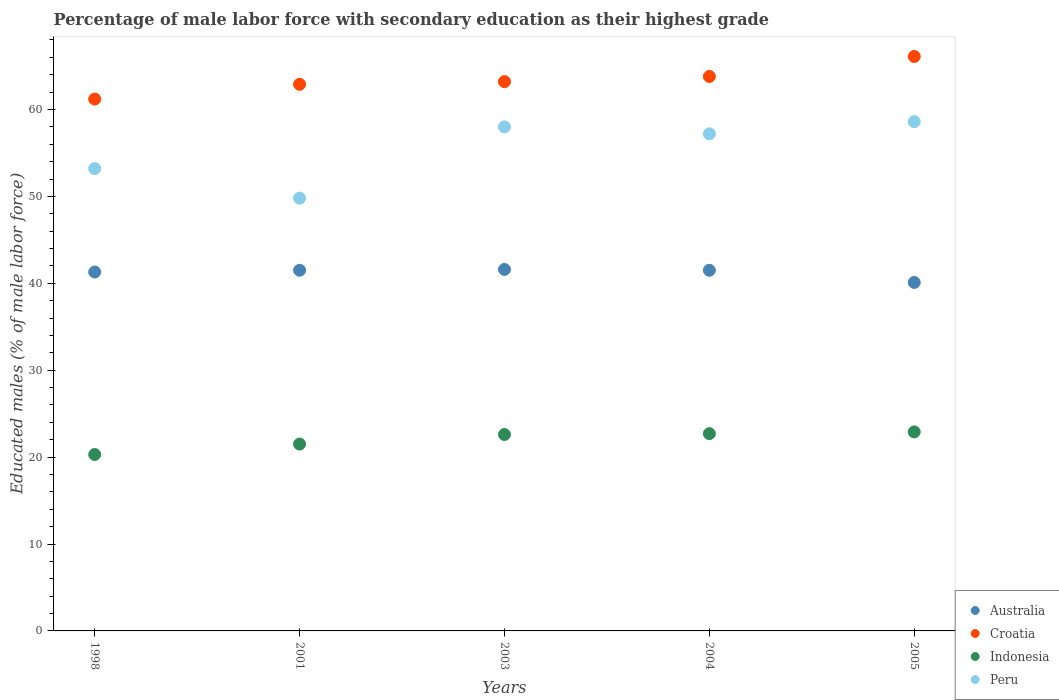How many different coloured dotlines are there?
Provide a short and direct response. 4. What is the percentage of male labor force with secondary education in Peru in 1998?
Offer a very short reply. 53.2. Across all years, what is the maximum percentage of male labor force with secondary education in Croatia?
Provide a short and direct response. 66.1. Across all years, what is the minimum percentage of male labor force with secondary education in Indonesia?
Your answer should be very brief. 20.3. In which year was the percentage of male labor force with secondary education in Indonesia minimum?
Provide a short and direct response. 1998. What is the total percentage of male labor force with secondary education in Indonesia in the graph?
Make the answer very short. 110. What is the difference between the percentage of male labor force with secondary education in Croatia in 2004 and that in 2005?
Make the answer very short. -2.3. What is the difference between the percentage of male labor force with secondary education in Peru in 1998 and the percentage of male labor force with secondary education in Croatia in 2004?
Your answer should be compact. -10.6. What is the average percentage of male labor force with secondary education in Australia per year?
Your answer should be very brief. 41.2. In the year 2004, what is the difference between the percentage of male labor force with secondary education in Croatia and percentage of male labor force with secondary education in Indonesia?
Make the answer very short. 41.1. In how many years, is the percentage of male labor force with secondary education in Australia greater than 58 %?
Keep it short and to the point. 0. What is the ratio of the percentage of male labor force with secondary education in Indonesia in 1998 to that in 2001?
Make the answer very short. 0.94. Is the difference between the percentage of male labor force with secondary education in Croatia in 2003 and 2005 greater than the difference between the percentage of male labor force with secondary education in Indonesia in 2003 and 2005?
Offer a terse response. No. What is the difference between the highest and the second highest percentage of male labor force with secondary education in Australia?
Make the answer very short. 0.1. What is the difference between the highest and the lowest percentage of male labor force with secondary education in Australia?
Your response must be concise. 1.5. In how many years, is the percentage of male labor force with secondary education in Peru greater than the average percentage of male labor force with secondary education in Peru taken over all years?
Your answer should be very brief. 3. Is the percentage of male labor force with secondary education in Peru strictly less than the percentage of male labor force with secondary education in Australia over the years?
Your answer should be very brief. No. How many years are there in the graph?
Keep it short and to the point. 5. What is the difference between two consecutive major ticks on the Y-axis?
Give a very brief answer. 10. How many legend labels are there?
Make the answer very short. 4. How are the legend labels stacked?
Offer a terse response. Vertical. What is the title of the graph?
Your answer should be very brief. Percentage of male labor force with secondary education as their highest grade. Does "Bosnia and Herzegovina" appear as one of the legend labels in the graph?
Offer a very short reply. No. What is the label or title of the Y-axis?
Your response must be concise. Educated males (% of male labor force). What is the Educated males (% of male labor force) of Australia in 1998?
Your answer should be compact. 41.3. What is the Educated males (% of male labor force) of Croatia in 1998?
Provide a short and direct response. 61.2. What is the Educated males (% of male labor force) of Indonesia in 1998?
Your answer should be compact. 20.3. What is the Educated males (% of male labor force) in Peru in 1998?
Offer a terse response. 53.2. What is the Educated males (% of male labor force) of Australia in 2001?
Give a very brief answer. 41.5. What is the Educated males (% of male labor force) in Croatia in 2001?
Ensure brevity in your answer.  62.9. What is the Educated males (% of male labor force) of Indonesia in 2001?
Provide a short and direct response. 21.5. What is the Educated males (% of male labor force) in Peru in 2001?
Your answer should be compact. 49.8. What is the Educated males (% of male labor force) in Australia in 2003?
Offer a terse response. 41.6. What is the Educated males (% of male labor force) in Croatia in 2003?
Make the answer very short. 63.2. What is the Educated males (% of male labor force) in Indonesia in 2003?
Offer a very short reply. 22.6. What is the Educated males (% of male labor force) of Australia in 2004?
Your answer should be very brief. 41.5. What is the Educated males (% of male labor force) in Croatia in 2004?
Provide a succinct answer. 63.8. What is the Educated males (% of male labor force) in Indonesia in 2004?
Provide a short and direct response. 22.7. What is the Educated males (% of male labor force) of Peru in 2004?
Your answer should be very brief. 57.2. What is the Educated males (% of male labor force) in Australia in 2005?
Offer a terse response. 40.1. What is the Educated males (% of male labor force) in Croatia in 2005?
Keep it short and to the point. 66.1. What is the Educated males (% of male labor force) of Indonesia in 2005?
Give a very brief answer. 22.9. What is the Educated males (% of male labor force) of Peru in 2005?
Give a very brief answer. 58.6. Across all years, what is the maximum Educated males (% of male labor force) of Australia?
Provide a succinct answer. 41.6. Across all years, what is the maximum Educated males (% of male labor force) in Croatia?
Your answer should be very brief. 66.1. Across all years, what is the maximum Educated males (% of male labor force) of Indonesia?
Keep it short and to the point. 22.9. Across all years, what is the maximum Educated males (% of male labor force) in Peru?
Offer a terse response. 58.6. Across all years, what is the minimum Educated males (% of male labor force) of Australia?
Offer a very short reply. 40.1. Across all years, what is the minimum Educated males (% of male labor force) of Croatia?
Ensure brevity in your answer.  61.2. Across all years, what is the minimum Educated males (% of male labor force) in Indonesia?
Keep it short and to the point. 20.3. Across all years, what is the minimum Educated males (% of male labor force) of Peru?
Provide a short and direct response. 49.8. What is the total Educated males (% of male labor force) of Australia in the graph?
Give a very brief answer. 206. What is the total Educated males (% of male labor force) of Croatia in the graph?
Ensure brevity in your answer.  317.2. What is the total Educated males (% of male labor force) in Indonesia in the graph?
Your response must be concise. 110. What is the total Educated males (% of male labor force) of Peru in the graph?
Your answer should be very brief. 276.8. What is the difference between the Educated males (% of male labor force) of Australia in 1998 and that in 2001?
Your answer should be compact. -0.2. What is the difference between the Educated males (% of male labor force) in Croatia in 1998 and that in 2001?
Provide a succinct answer. -1.7. What is the difference between the Educated males (% of male labor force) of Indonesia in 1998 and that in 2001?
Offer a terse response. -1.2. What is the difference between the Educated males (% of male labor force) of Croatia in 1998 and that in 2003?
Keep it short and to the point. -2. What is the difference between the Educated males (% of male labor force) in Indonesia in 1998 and that in 2003?
Provide a short and direct response. -2.3. What is the difference between the Educated males (% of male labor force) of Peru in 1998 and that in 2003?
Your answer should be compact. -4.8. What is the difference between the Educated males (% of male labor force) of Indonesia in 2001 and that in 2003?
Provide a succinct answer. -1.1. What is the difference between the Educated males (% of male labor force) in Peru in 2001 and that in 2003?
Provide a short and direct response. -8.2. What is the difference between the Educated males (% of male labor force) of Australia in 2001 and that in 2004?
Your answer should be very brief. 0. What is the difference between the Educated males (% of male labor force) in Croatia in 2001 and that in 2004?
Offer a terse response. -0.9. What is the difference between the Educated males (% of male labor force) in Peru in 2001 and that in 2004?
Give a very brief answer. -7.4. What is the difference between the Educated males (% of male labor force) in Croatia in 2001 and that in 2005?
Offer a terse response. -3.2. What is the difference between the Educated males (% of male labor force) in Croatia in 2003 and that in 2004?
Make the answer very short. -0.6. What is the difference between the Educated males (% of male labor force) of Indonesia in 2003 and that in 2004?
Your response must be concise. -0.1. What is the difference between the Educated males (% of male labor force) in Peru in 2003 and that in 2004?
Keep it short and to the point. 0.8. What is the difference between the Educated males (% of male labor force) of Croatia in 2003 and that in 2005?
Keep it short and to the point. -2.9. What is the difference between the Educated males (% of male labor force) of Peru in 2003 and that in 2005?
Your response must be concise. -0.6. What is the difference between the Educated males (% of male labor force) of Australia in 2004 and that in 2005?
Keep it short and to the point. 1.4. What is the difference between the Educated males (% of male labor force) of Croatia in 2004 and that in 2005?
Keep it short and to the point. -2.3. What is the difference between the Educated males (% of male labor force) of Indonesia in 2004 and that in 2005?
Provide a short and direct response. -0.2. What is the difference between the Educated males (% of male labor force) of Peru in 2004 and that in 2005?
Your response must be concise. -1.4. What is the difference between the Educated males (% of male labor force) in Australia in 1998 and the Educated males (% of male labor force) in Croatia in 2001?
Make the answer very short. -21.6. What is the difference between the Educated males (% of male labor force) in Australia in 1998 and the Educated males (% of male labor force) in Indonesia in 2001?
Your answer should be very brief. 19.8. What is the difference between the Educated males (% of male labor force) in Croatia in 1998 and the Educated males (% of male labor force) in Indonesia in 2001?
Your answer should be compact. 39.7. What is the difference between the Educated males (% of male labor force) of Indonesia in 1998 and the Educated males (% of male labor force) of Peru in 2001?
Provide a succinct answer. -29.5. What is the difference between the Educated males (% of male labor force) in Australia in 1998 and the Educated males (% of male labor force) in Croatia in 2003?
Offer a very short reply. -21.9. What is the difference between the Educated males (% of male labor force) of Australia in 1998 and the Educated males (% of male labor force) of Peru in 2003?
Keep it short and to the point. -16.7. What is the difference between the Educated males (% of male labor force) of Croatia in 1998 and the Educated males (% of male labor force) of Indonesia in 2003?
Keep it short and to the point. 38.6. What is the difference between the Educated males (% of male labor force) in Indonesia in 1998 and the Educated males (% of male labor force) in Peru in 2003?
Ensure brevity in your answer.  -37.7. What is the difference between the Educated males (% of male labor force) in Australia in 1998 and the Educated males (% of male labor force) in Croatia in 2004?
Give a very brief answer. -22.5. What is the difference between the Educated males (% of male labor force) in Australia in 1998 and the Educated males (% of male labor force) in Indonesia in 2004?
Give a very brief answer. 18.6. What is the difference between the Educated males (% of male labor force) of Australia in 1998 and the Educated males (% of male labor force) of Peru in 2004?
Give a very brief answer. -15.9. What is the difference between the Educated males (% of male labor force) of Croatia in 1998 and the Educated males (% of male labor force) of Indonesia in 2004?
Give a very brief answer. 38.5. What is the difference between the Educated males (% of male labor force) in Indonesia in 1998 and the Educated males (% of male labor force) in Peru in 2004?
Offer a terse response. -36.9. What is the difference between the Educated males (% of male labor force) in Australia in 1998 and the Educated males (% of male labor force) in Croatia in 2005?
Your answer should be very brief. -24.8. What is the difference between the Educated males (% of male labor force) in Australia in 1998 and the Educated males (% of male labor force) in Peru in 2005?
Offer a terse response. -17.3. What is the difference between the Educated males (% of male labor force) of Croatia in 1998 and the Educated males (% of male labor force) of Indonesia in 2005?
Give a very brief answer. 38.3. What is the difference between the Educated males (% of male labor force) of Croatia in 1998 and the Educated males (% of male labor force) of Peru in 2005?
Provide a succinct answer. 2.6. What is the difference between the Educated males (% of male labor force) of Indonesia in 1998 and the Educated males (% of male labor force) of Peru in 2005?
Ensure brevity in your answer.  -38.3. What is the difference between the Educated males (% of male labor force) of Australia in 2001 and the Educated males (% of male labor force) of Croatia in 2003?
Make the answer very short. -21.7. What is the difference between the Educated males (% of male labor force) of Australia in 2001 and the Educated males (% of male labor force) of Peru in 2003?
Make the answer very short. -16.5. What is the difference between the Educated males (% of male labor force) in Croatia in 2001 and the Educated males (% of male labor force) in Indonesia in 2003?
Give a very brief answer. 40.3. What is the difference between the Educated males (% of male labor force) of Croatia in 2001 and the Educated males (% of male labor force) of Peru in 2003?
Give a very brief answer. 4.9. What is the difference between the Educated males (% of male labor force) in Indonesia in 2001 and the Educated males (% of male labor force) in Peru in 2003?
Offer a terse response. -36.5. What is the difference between the Educated males (% of male labor force) in Australia in 2001 and the Educated males (% of male labor force) in Croatia in 2004?
Provide a short and direct response. -22.3. What is the difference between the Educated males (% of male labor force) in Australia in 2001 and the Educated males (% of male labor force) in Peru in 2004?
Make the answer very short. -15.7. What is the difference between the Educated males (% of male labor force) in Croatia in 2001 and the Educated males (% of male labor force) in Indonesia in 2004?
Offer a terse response. 40.2. What is the difference between the Educated males (% of male labor force) in Indonesia in 2001 and the Educated males (% of male labor force) in Peru in 2004?
Provide a succinct answer. -35.7. What is the difference between the Educated males (% of male labor force) in Australia in 2001 and the Educated males (% of male labor force) in Croatia in 2005?
Offer a very short reply. -24.6. What is the difference between the Educated males (% of male labor force) of Australia in 2001 and the Educated males (% of male labor force) of Indonesia in 2005?
Ensure brevity in your answer.  18.6. What is the difference between the Educated males (% of male labor force) in Australia in 2001 and the Educated males (% of male labor force) in Peru in 2005?
Offer a terse response. -17.1. What is the difference between the Educated males (% of male labor force) of Croatia in 2001 and the Educated males (% of male labor force) of Indonesia in 2005?
Offer a very short reply. 40. What is the difference between the Educated males (% of male labor force) of Croatia in 2001 and the Educated males (% of male labor force) of Peru in 2005?
Ensure brevity in your answer.  4.3. What is the difference between the Educated males (% of male labor force) of Indonesia in 2001 and the Educated males (% of male labor force) of Peru in 2005?
Provide a succinct answer. -37.1. What is the difference between the Educated males (% of male labor force) of Australia in 2003 and the Educated males (% of male labor force) of Croatia in 2004?
Your answer should be compact. -22.2. What is the difference between the Educated males (% of male labor force) of Australia in 2003 and the Educated males (% of male labor force) of Indonesia in 2004?
Your answer should be compact. 18.9. What is the difference between the Educated males (% of male labor force) of Australia in 2003 and the Educated males (% of male labor force) of Peru in 2004?
Offer a terse response. -15.6. What is the difference between the Educated males (% of male labor force) of Croatia in 2003 and the Educated males (% of male labor force) of Indonesia in 2004?
Provide a short and direct response. 40.5. What is the difference between the Educated males (% of male labor force) in Indonesia in 2003 and the Educated males (% of male labor force) in Peru in 2004?
Provide a succinct answer. -34.6. What is the difference between the Educated males (% of male labor force) of Australia in 2003 and the Educated males (% of male labor force) of Croatia in 2005?
Ensure brevity in your answer.  -24.5. What is the difference between the Educated males (% of male labor force) in Australia in 2003 and the Educated males (% of male labor force) in Indonesia in 2005?
Provide a succinct answer. 18.7. What is the difference between the Educated males (% of male labor force) of Croatia in 2003 and the Educated males (% of male labor force) of Indonesia in 2005?
Make the answer very short. 40.3. What is the difference between the Educated males (% of male labor force) in Indonesia in 2003 and the Educated males (% of male labor force) in Peru in 2005?
Your answer should be compact. -36. What is the difference between the Educated males (% of male labor force) in Australia in 2004 and the Educated males (% of male labor force) in Croatia in 2005?
Your response must be concise. -24.6. What is the difference between the Educated males (% of male labor force) in Australia in 2004 and the Educated males (% of male labor force) in Indonesia in 2005?
Your answer should be very brief. 18.6. What is the difference between the Educated males (% of male labor force) of Australia in 2004 and the Educated males (% of male labor force) of Peru in 2005?
Your answer should be compact. -17.1. What is the difference between the Educated males (% of male labor force) of Croatia in 2004 and the Educated males (% of male labor force) of Indonesia in 2005?
Make the answer very short. 40.9. What is the difference between the Educated males (% of male labor force) of Indonesia in 2004 and the Educated males (% of male labor force) of Peru in 2005?
Provide a succinct answer. -35.9. What is the average Educated males (% of male labor force) in Australia per year?
Your answer should be compact. 41.2. What is the average Educated males (% of male labor force) in Croatia per year?
Keep it short and to the point. 63.44. What is the average Educated males (% of male labor force) in Peru per year?
Keep it short and to the point. 55.36. In the year 1998, what is the difference between the Educated males (% of male labor force) in Australia and Educated males (% of male labor force) in Croatia?
Offer a terse response. -19.9. In the year 1998, what is the difference between the Educated males (% of male labor force) of Australia and Educated males (% of male labor force) of Peru?
Offer a very short reply. -11.9. In the year 1998, what is the difference between the Educated males (% of male labor force) in Croatia and Educated males (% of male labor force) in Indonesia?
Your answer should be compact. 40.9. In the year 1998, what is the difference between the Educated males (% of male labor force) in Indonesia and Educated males (% of male labor force) in Peru?
Your answer should be very brief. -32.9. In the year 2001, what is the difference between the Educated males (% of male labor force) in Australia and Educated males (% of male labor force) in Croatia?
Your answer should be very brief. -21.4. In the year 2001, what is the difference between the Educated males (% of male labor force) in Australia and Educated males (% of male labor force) in Indonesia?
Offer a terse response. 20. In the year 2001, what is the difference between the Educated males (% of male labor force) of Croatia and Educated males (% of male labor force) of Indonesia?
Provide a succinct answer. 41.4. In the year 2001, what is the difference between the Educated males (% of male labor force) of Croatia and Educated males (% of male labor force) of Peru?
Keep it short and to the point. 13.1. In the year 2001, what is the difference between the Educated males (% of male labor force) of Indonesia and Educated males (% of male labor force) of Peru?
Your answer should be compact. -28.3. In the year 2003, what is the difference between the Educated males (% of male labor force) of Australia and Educated males (% of male labor force) of Croatia?
Provide a succinct answer. -21.6. In the year 2003, what is the difference between the Educated males (% of male labor force) of Australia and Educated males (% of male labor force) of Indonesia?
Give a very brief answer. 19. In the year 2003, what is the difference between the Educated males (% of male labor force) of Australia and Educated males (% of male labor force) of Peru?
Make the answer very short. -16.4. In the year 2003, what is the difference between the Educated males (% of male labor force) of Croatia and Educated males (% of male labor force) of Indonesia?
Your response must be concise. 40.6. In the year 2003, what is the difference between the Educated males (% of male labor force) of Indonesia and Educated males (% of male labor force) of Peru?
Your answer should be very brief. -35.4. In the year 2004, what is the difference between the Educated males (% of male labor force) in Australia and Educated males (% of male labor force) in Croatia?
Offer a very short reply. -22.3. In the year 2004, what is the difference between the Educated males (% of male labor force) of Australia and Educated males (% of male labor force) of Indonesia?
Your response must be concise. 18.8. In the year 2004, what is the difference between the Educated males (% of male labor force) of Australia and Educated males (% of male labor force) of Peru?
Offer a very short reply. -15.7. In the year 2004, what is the difference between the Educated males (% of male labor force) of Croatia and Educated males (% of male labor force) of Indonesia?
Your answer should be compact. 41.1. In the year 2004, what is the difference between the Educated males (% of male labor force) of Indonesia and Educated males (% of male labor force) of Peru?
Ensure brevity in your answer.  -34.5. In the year 2005, what is the difference between the Educated males (% of male labor force) of Australia and Educated males (% of male labor force) of Croatia?
Your answer should be compact. -26. In the year 2005, what is the difference between the Educated males (% of male labor force) of Australia and Educated males (% of male labor force) of Indonesia?
Your answer should be very brief. 17.2. In the year 2005, what is the difference between the Educated males (% of male labor force) in Australia and Educated males (% of male labor force) in Peru?
Provide a short and direct response. -18.5. In the year 2005, what is the difference between the Educated males (% of male labor force) in Croatia and Educated males (% of male labor force) in Indonesia?
Provide a short and direct response. 43.2. In the year 2005, what is the difference between the Educated males (% of male labor force) of Indonesia and Educated males (% of male labor force) of Peru?
Provide a short and direct response. -35.7. What is the ratio of the Educated males (% of male labor force) of Australia in 1998 to that in 2001?
Offer a very short reply. 1. What is the ratio of the Educated males (% of male labor force) in Croatia in 1998 to that in 2001?
Ensure brevity in your answer.  0.97. What is the ratio of the Educated males (% of male labor force) of Indonesia in 1998 to that in 2001?
Make the answer very short. 0.94. What is the ratio of the Educated males (% of male labor force) in Peru in 1998 to that in 2001?
Give a very brief answer. 1.07. What is the ratio of the Educated males (% of male labor force) in Croatia in 1998 to that in 2003?
Make the answer very short. 0.97. What is the ratio of the Educated males (% of male labor force) of Indonesia in 1998 to that in 2003?
Make the answer very short. 0.9. What is the ratio of the Educated males (% of male labor force) of Peru in 1998 to that in 2003?
Your answer should be compact. 0.92. What is the ratio of the Educated males (% of male labor force) of Australia in 1998 to that in 2004?
Provide a short and direct response. 1. What is the ratio of the Educated males (% of male labor force) in Croatia in 1998 to that in 2004?
Your answer should be compact. 0.96. What is the ratio of the Educated males (% of male labor force) of Indonesia in 1998 to that in 2004?
Offer a terse response. 0.89. What is the ratio of the Educated males (% of male labor force) of Peru in 1998 to that in 2004?
Offer a very short reply. 0.93. What is the ratio of the Educated males (% of male labor force) of Australia in 1998 to that in 2005?
Provide a short and direct response. 1.03. What is the ratio of the Educated males (% of male labor force) in Croatia in 1998 to that in 2005?
Make the answer very short. 0.93. What is the ratio of the Educated males (% of male labor force) in Indonesia in 1998 to that in 2005?
Ensure brevity in your answer.  0.89. What is the ratio of the Educated males (% of male labor force) of Peru in 1998 to that in 2005?
Offer a terse response. 0.91. What is the ratio of the Educated males (% of male labor force) of Croatia in 2001 to that in 2003?
Your answer should be compact. 1. What is the ratio of the Educated males (% of male labor force) in Indonesia in 2001 to that in 2003?
Give a very brief answer. 0.95. What is the ratio of the Educated males (% of male labor force) in Peru in 2001 to that in 2003?
Offer a terse response. 0.86. What is the ratio of the Educated males (% of male labor force) of Australia in 2001 to that in 2004?
Your answer should be compact. 1. What is the ratio of the Educated males (% of male labor force) of Croatia in 2001 to that in 2004?
Your answer should be compact. 0.99. What is the ratio of the Educated males (% of male labor force) of Indonesia in 2001 to that in 2004?
Provide a succinct answer. 0.95. What is the ratio of the Educated males (% of male labor force) of Peru in 2001 to that in 2004?
Your answer should be very brief. 0.87. What is the ratio of the Educated males (% of male labor force) of Australia in 2001 to that in 2005?
Keep it short and to the point. 1.03. What is the ratio of the Educated males (% of male labor force) in Croatia in 2001 to that in 2005?
Provide a short and direct response. 0.95. What is the ratio of the Educated males (% of male labor force) of Indonesia in 2001 to that in 2005?
Keep it short and to the point. 0.94. What is the ratio of the Educated males (% of male labor force) of Peru in 2001 to that in 2005?
Your answer should be very brief. 0.85. What is the ratio of the Educated males (% of male labor force) of Australia in 2003 to that in 2004?
Keep it short and to the point. 1. What is the ratio of the Educated males (% of male labor force) of Croatia in 2003 to that in 2004?
Make the answer very short. 0.99. What is the ratio of the Educated males (% of male labor force) of Indonesia in 2003 to that in 2004?
Offer a very short reply. 1. What is the ratio of the Educated males (% of male labor force) of Australia in 2003 to that in 2005?
Offer a terse response. 1.04. What is the ratio of the Educated males (% of male labor force) of Croatia in 2003 to that in 2005?
Keep it short and to the point. 0.96. What is the ratio of the Educated males (% of male labor force) in Indonesia in 2003 to that in 2005?
Offer a very short reply. 0.99. What is the ratio of the Educated males (% of male labor force) of Australia in 2004 to that in 2005?
Give a very brief answer. 1.03. What is the ratio of the Educated males (% of male labor force) of Croatia in 2004 to that in 2005?
Provide a short and direct response. 0.97. What is the ratio of the Educated males (% of male labor force) of Indonesia in 2004 to that in 2005?
Offer a terse response. 0.99. What is the ratio of the Educated males (% of male labor force) in Peru in 2004 to that in 2005?
Offer a terse response. 0.98. What is the difference between the highest and the second highest Educated males (% of male labor force) of Croatia?
Offer a terse response. 2.3. 